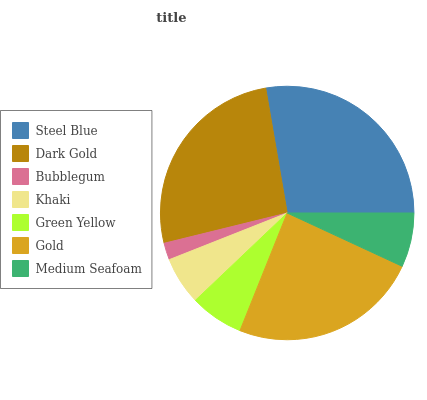Is Bubblegum the minimum?
Answer yes or no. Yes. Is Steel Blue the maximum?
Answer yes or no. Yes. Is Dark Gold the minimum?
Answer yes or no. No. Is Dark Gold the maximum?
Answer yes or no. No. Is Steel Blue greater than Dark Gold?
Answer yes or no. Yes. Is Dark Gold less than Steel Blue?
Answer yes or no. Yes. Is Dark Gold greater than Steel Blue?
Answer yes or no. No. Is Steel Blue less than Dark Gold?
Answer yes or no. No. Is Medium Seafoam the high median?
Answer yes or no. Yes. Is Medium Seafoam the low median?
Answer yes or no. Yes. Is Dark Gold the high median?
Answer yes or no. No. Is Steel Blue the low median?
Answer yes or no. No. 